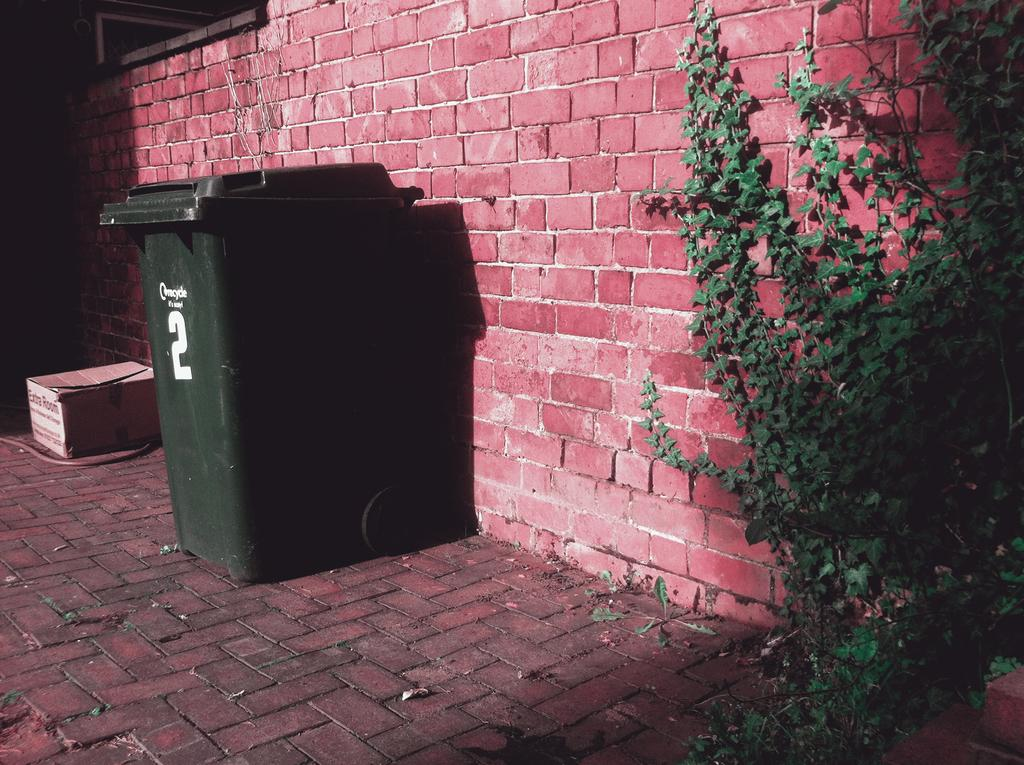<image>
Render a clear and concise summary of the photo. A green trash can with the number 2 on it sits against a brick wall 